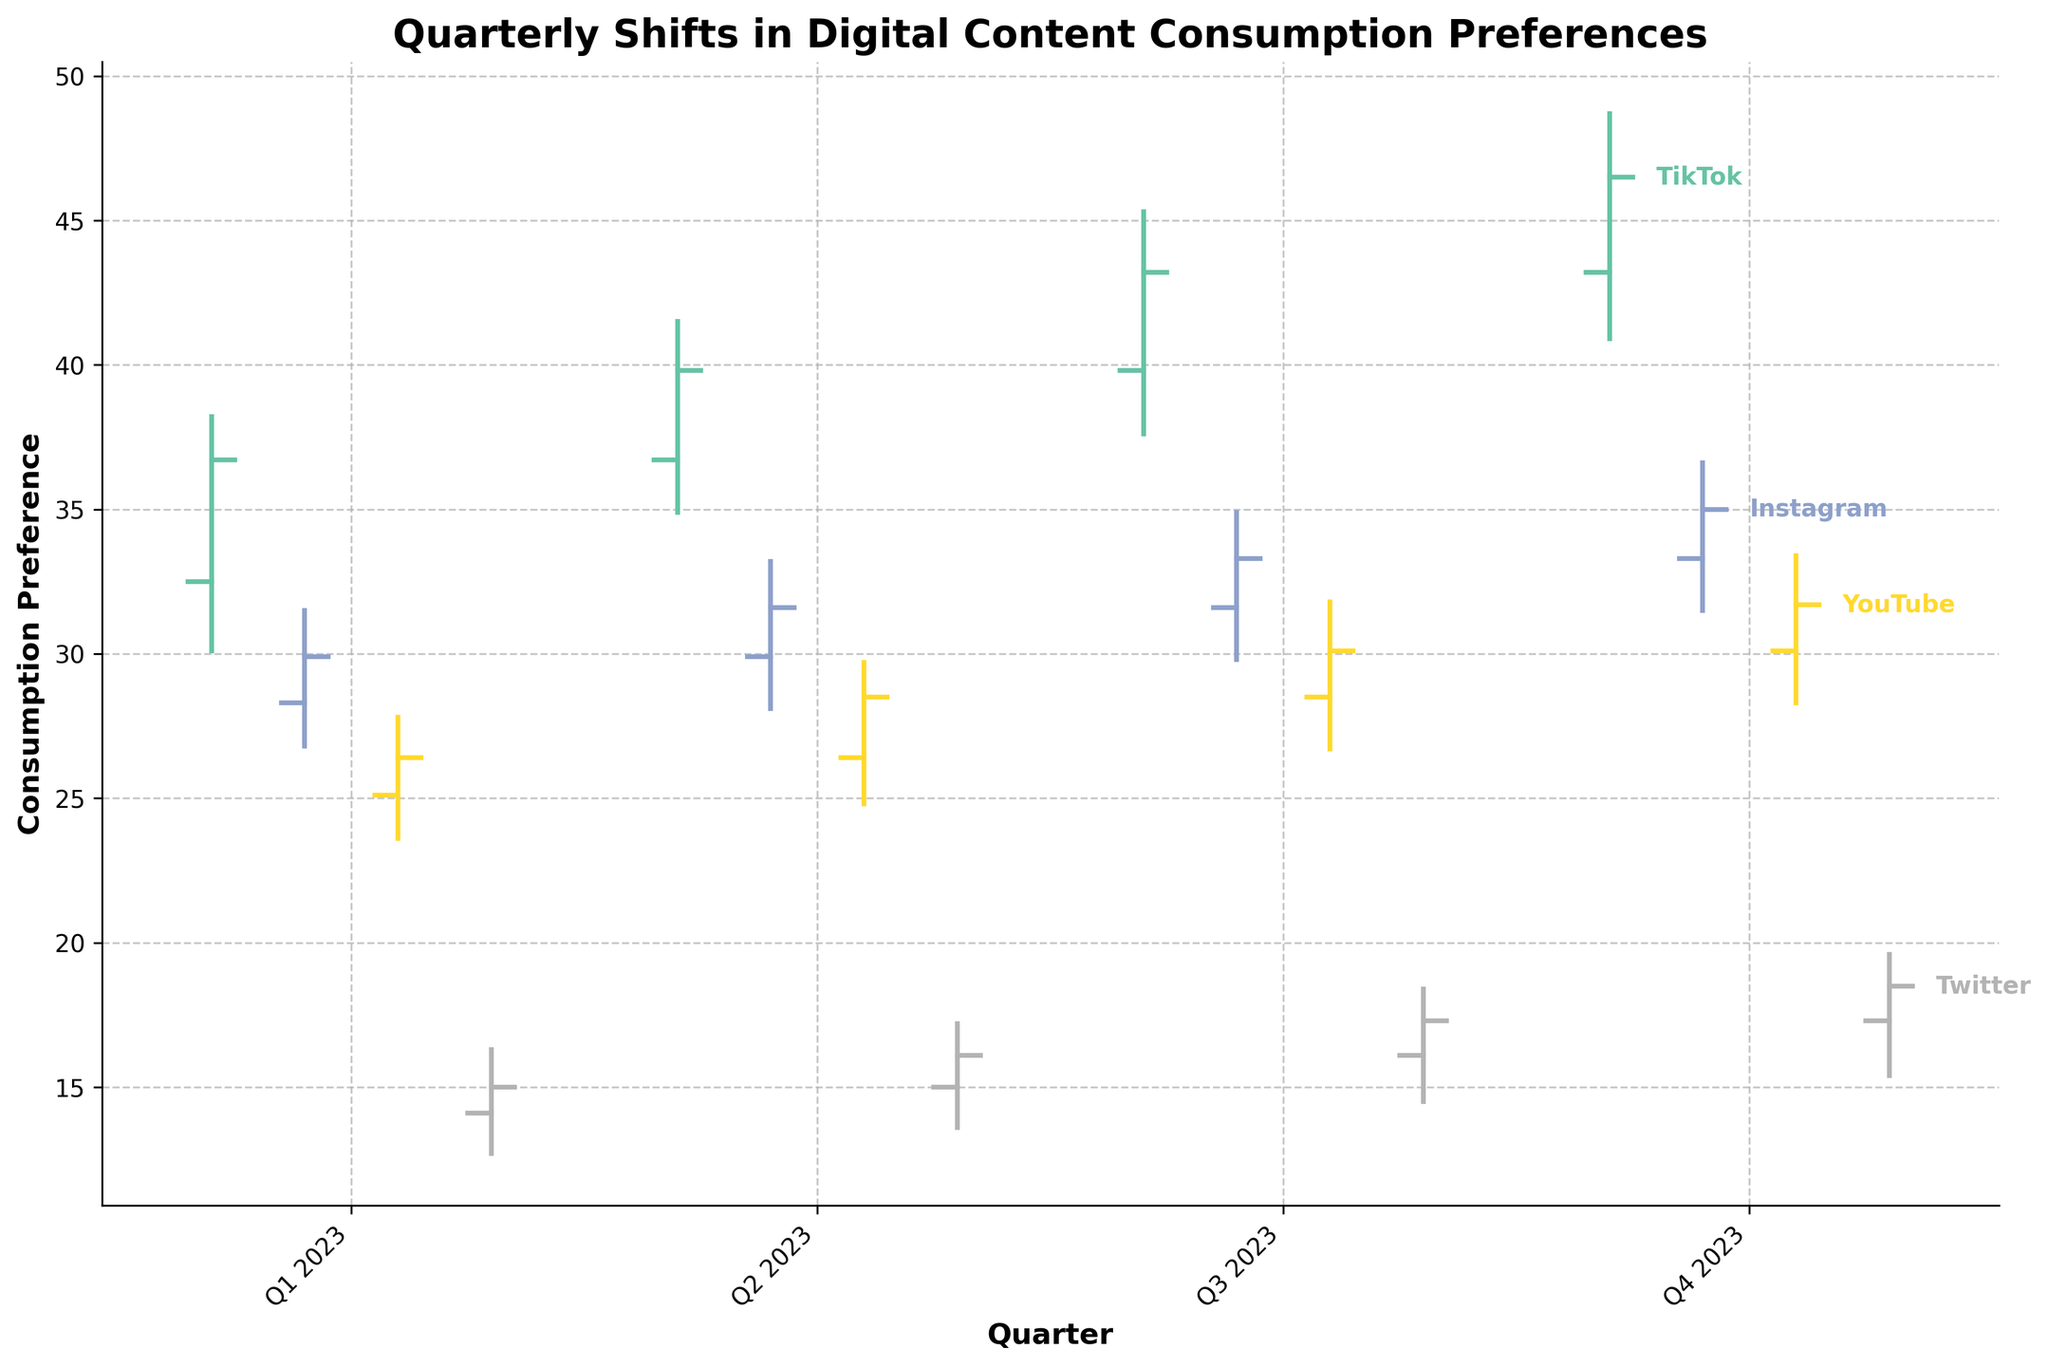What is the title of the figure? The title of the figure is shown at the top.
Answer: Quarterly Shifts in Digital Content Consumption Preferences Which platform had the highest consumption preference in Q4 2023? By looking at the highest points for each platform in Q4 2023, TikTok has the highest consumption preference.
Answer: TikTok During which quarter did Instagram have its lowest consumption preference? Checking the 'Low' values for Instagram across all quarters, the lowest is in Q1 2023.
Answer: Q1 2023 What is the overall trend for YouTube's consumption preferences from Q1 2023 to Q4 2023? Observing the Open and Close values for YouTube from Q1 to Q4 2023, all values steadily increase over time indicating an upward trend.
Answer: Upward trend How does TikTok's consumption preference in Q2 2023 compare to Q1 2023? Compare the Open and Close values of TikTok in Q1 and Q2 2023. Both Open and Close values in Q2 2023 are higher than those in Q1 2023.
Answer: Higher Which quarter shows the most significant increase in Twitter's consumption preferences from the previous quarter? By looking at the Close values and comparing each quarter with the previous one, Q3 to Q4 2023 shows the largest increase (17.3 to 18.5).
Answer: Q4 2023 What is the average Open value for Instagram in 2023? Calculate the average of the Open values for Instagram across all four quarters: (28.3 + 29.9 + 31.6 + 33.3) / 4 = 30.775.
Answer: 30.775 Which platform has the least volatility in consumption preferences in Q3 2023? Volatility can be estimated by the difference between the High and Low values. Compute this for each platform in Q3 2023 and compare them. Instagram: 34.9-29.8=5.1, YouTube: 31.8-26.7=5.1, Twitter: 18.4-14.5=3.9, TikTok: 45.3-37.6=7.7. Twitter has the lowest difference.
Answer: Twitter What is the difference between the highest and lowest Close values for TikTok across all quarters? Identify the highest and lowest Close values for TikTok: highest is 46.5 (Q4 2023), and the lowest is 36.7 (Q1 2023). Difference is 46.5 - 36.7 = 9.8.
Answer: 9.8 How did Instagram's consumption preference change from Q1 2023 to Q2 2023? Compare the Close values: Q1 2023 (29.9) to Q2 2023 (31.6). The change is an increase by 31.6 - 29.9 = 1.7.
Answer: Increased by 1.7 